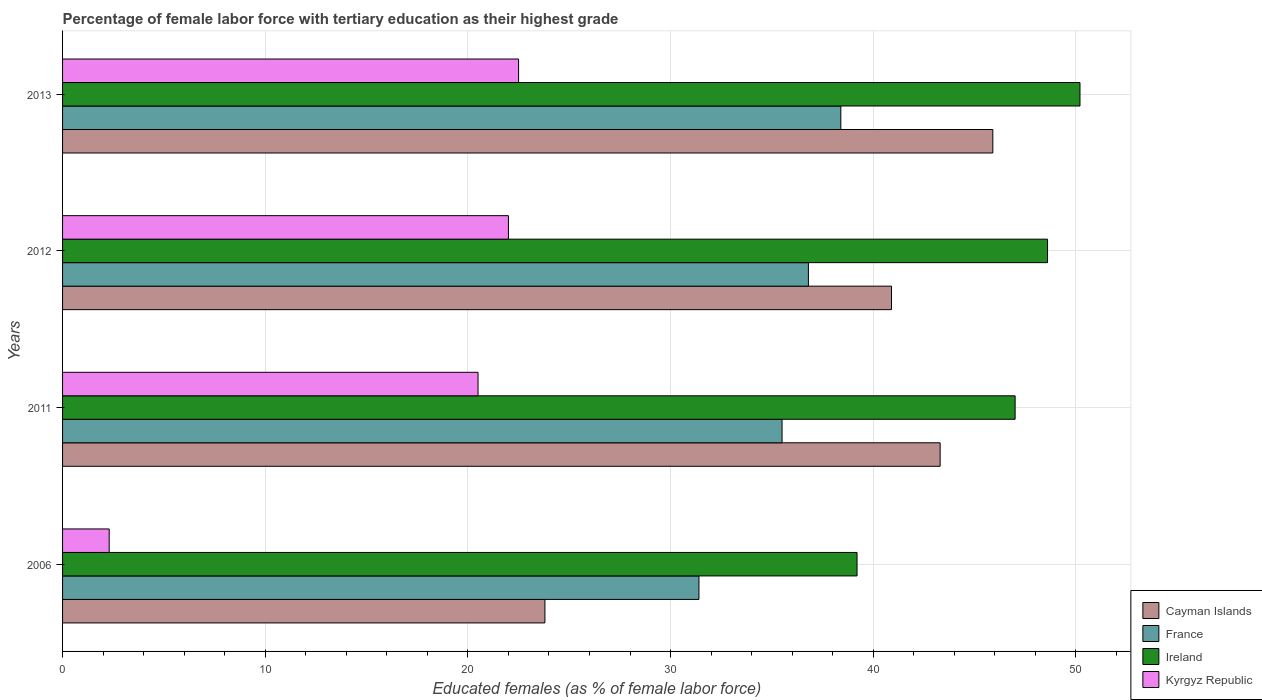Are the number of bars on each tick of the Y-axis equal?
Keep it short and to the point. Yes. How many bars are there on the 1st tick from the top?
Provide a short and direct response. 4. What is the label of the 1st group of bars from the top?
Make the answer very short. 2013. What is the percentage of female labor force with tertiary education in France in 2012?
Give a very brief answer. 36.8. Across all years, what is the maximum percentage of female labor force with tertiary education in Cayman Islands?
Your response must be concise. 45.9. Across all years, what is the minimum percentage of female labor force with tertiary education in Cayman Islands?
Offer a very short reply. 23.8. What is the total percentage of female labor force with tertiary education in Kyrgyz Republic in the graph?
Give a very brief answer. 67.3. What is the difference between the percentage of female labor force with tertiary education in Ireland in 2011 and that in 2013?
Make the answer very short. -3.2. What is the difference between the percentage of female labor force with tertiary education in Ireland in 2006 and the percentage of female labor force with tertiary education in Cayman Islands in 2012?
Provide a short and direct response. -1.7. What is the average percentage of female labor force with tertiary education in France per year?
Provide a succinct answer. 35.53. In the year 2011, what is the difference between the percentage of female labor force with tertiary education in Kyrgyz Republic and percentage of female labor force with tertiary education in Ireland?
Your answer should be compact. -26.5. In how many years, is the percentage of female labor force with tertiary education in Cayman Islands greater than 38 %?
Your answer should be compact. 3. What is the ratio of the percentage of female labor force with tertiary education in Ireland in 2006 to that in 2013?
Your answer should be compact. 0.78. Is the percentage of female labor force with tertiary education in Cayman Islands in 2011 less than that in 2012?
Make the answer very short. No. Is the difference between the percentage of female labor force with tertiary education in Kyrgyz Republic in 2006 and 2012 greater than the difference between the percentage of female labor force with tertiary education in Ireland in 2006 and 2012?
Your response must be concise. No. What is the difference between the highest and the lowest percentage of female labor force with tertiary education in Ireland?
Ensure brevity in your answer.  11. Is the sum of the percentage of female labor force with tertiary education in France in 2011 and 2012 greater than the maximum percentage of female labor force with tertiary education in Kyrgyz Republic across all years?
Your answer should be very brief. Yes. Is it the case that in every year, the sum of the percentage of female labor force with tertiary education in Cayman Islands and percentage of female labor force with tertiary education in Kyrgyz Republic is greater than the sum of percentage of female labor force with tertiary education in France and percentage of female labor force with tertiary education in Ireland?
Ensure brevity in your answer.  No. What does the 4th bar from the top in 2012 represents?
Offer a very short reply. Cayman Islands. What does the 2nd bar from the bottom in 2011 represents?
Make the answer very short. France. Is it the case that in every year, the sum of the percentage of female labor force with tertiary education in Cayman Islands and percentage of female labor force with tertiary education in France is greater than the percentage of female labor force with tertiary education in Ireland?
Offer a very short reply. Yes. How many bars are there?
Keep it short and to the point. 16. Are all the bars in the graph horizontal?
Offer a very short reply. Yes. What is the difference between two consecutive major ticks on the X-axis?
Offer a terse response. 10. Does the graph contain any zero values?
Give a very brief answer. No. Does the graph contain grids?
Make the answer very short. Yes. Where does the legend appear in the graph?
Provide a short and direct response. Bottom right. What is the title of the graph?
Ensure brevity in your answer.  Percentage of female labor force with tertiary education as their highest grade. What is the label or title of the X-axis?
Make the answer very short. Educated females (as % of female labor force). What is the Educated females (as % of female labor force) of Cayman Islands in 2006?
Provide a succinct answer. 23.8. What is the Educated females (as % of female labor force) of France in 2006?
Your answer should be very brief. 31.4. What is the Educated females (as % of female labor force) of Ireland in 2006?
Ensure brevity in your answer.  39.2. What is the Educated females (as % of female labor force) of Kyrgyz Republic in 2006?
Give a very brief answer. 2.3. What is the Educated females (as % of female labor force) of Cayman Islands in 2011?
Provide a short and direct response. 43.3. What is the Educated females (as % of female labor force) in France in 2011?
Ensure brevity in your answer.  35.5. What is the Educated females (as % of female labor force) of Ireland in 2011?
Your answer should be very brief. 47. What is the Educated females (as % of female labor force) of Cayman Islands in 2012?
Offer a terse response. 40.9. What is the Educated females (as % of female labor force) in France in 2012?
Provide a short and direct response. 36.8. What is the Educated females (as % of female labor force) in Ireland in 2012?
Ensure brevity in your answer.  48.6. What is the Educated females (as % of female labor force) in Kyrgyz Republic in 2012?
Your answer should be very brief. 22. What is the Educated females (as % of female labor force) in Cayman Islands in 2013?
Your response must be concise. 45.9. What is the Educated females (as % of female labor force) in France in 2013?
Provide a short and direct response. 38.4. What is the Educated females (as % of female labor force) of Ireland in 2013?
Provide a short and direct response. 50.2. What is the Educated females (as % of female labor force) of Kyrgyz Republic in 2013?
Give a very brief answer. 22.5. Across all years, what is the maximum Educated females (as % of female labor force) in Cayman Islands?
Your answer should be very brief. 45.9. Across all years, what is the maximum Educated females (as % of female labor force) of France?
Your response must be concise. 38.4. Across all years, what is the maximum Educated females (as % of female labor force) of Ireland?
Give a very brief answer. 50.2. Across all years, what is the minimum Educated females (as % of female labor force) in Cayman Islands?
Your answer should be very brief. 23.8. Across all years, what is the minimum Educated females (as % of female labor force) in France?
Offer a terse response. 31.4. Across all years, what is the minimum Educated females (as % of female labor force) in Ireland?
Your answer should be very brief. 39.2. Across all years, what is the minimum Educated females (as % of female labor force) in Kyrgyz Republic?
Keep it short and to the point. 2.3. What is the total Educated females (as % of female labor force) in Cayman Islands in the graph?
Offer a very short reply. 153.9. What is the total Educated females (as % of female labor force) of France in the graph?
Make the answer very short. 142.1. What is the total Educated females (as % of female labor force) in Ireland in the graph?
Your answer should be very brief. 185. What is the total Educated females (as % of female labor force) of Kyrgyz Republic in the graph?
Your answer should be very brief. 67.3. What is the difference between the Educated females (as % of female labor force) of Cayman Islands in 2006 and that in 2011?
Your answer should be very brief. -19.5. What is the difference between the Educated females (as % of female labor force) of France in 2006 and that in 2011?
Provide a succinct answer. -4.1. What is the difference between the Educated females (as % of female labor force) of Kyrgyz Republic in 2006 and that in 2011?
Your answer should be compact. -18.2. What is the difference between the Educated females (as % of female labor force) in Cayman Islands in 2006 and that in 2012?
Keep it short and to the point. -17.1. What is the difference between the Educated females (as % of female labor force) of France in 2006 and that in 2012?
Your answer should be very brief. -5.4. What is the difference between the Educated females (as % of female labor force) in Ireland in 2006 and that in 2012?
Offer a terse response. -9.4. What is the difference between the Educated females (as % of female labor force) of Kyrgyz Republic in 2006 and that in 2012?
Give a very brief answer. -19.7. What is the difference between the Educated females (as % of female labor force) of Cayman Islands in 2006 and that in 2013?
Provide a short and direct response. -22.1. What is the difference between the Educated females (as % of female labor force) of Kyrgyz Republic in 2006 and that in 2013?
Keep it short and to the point. -20.2. What is the difference between the Educated females (as % of female labor force) of France in 2011 and that in 2012?
Keep it short and to the point. -1.3. What is the difference between the Educated females (as % of female labor force) in Kyrgyz Republic in 2011 and that in 2012?
Provide a succinct answer. -1.5. What is the difference between the Educated females (as % of female labor force) of Cayman Islands in 2011 and that in 2013?
Provide a succinct answer. -2.6. What is the difference between the Educated females (as % of female labor force) of France in 2011 and that in 2013?
Keep it short and to the point. -2.9. What is the difference between the Educated females (as % of female labor force) in Ireland in 2011 and that in 2013?
Make the answer very short. -3.2. What is the difference between the Educated females (as % of female labor force) in Kyrgyz Republic in 2011 and that in 2013?
Make the answer very short. -2. What is the difference between the Educated females (as % of female labor force) in Cayman Islands in 2012 and that in 2013?
Provide a short and direct response. -5. What is the difference between the Educated females (as % of female labor force) in France in 2012 and that in 2013?
Your response must be concise. -1.6. What is the difference between the Educated females (as % of female labor force) in Ireland in 2012 and that in 2013?
Keep it short and to the point. -1.6. What is the difference between the Educated females (as % of female labor force) in Kyrgyz Republic in 2012 and that in 2013?
Offer a very short reply. -0.5. What is the difference between the Educated females (as % of female labor force) in Cayman Islands in 2006 and the Educated females (as % of female labor force) in France in 2011?
Make the answer very short. -11.7. What is the difference between the Educated females (as % of female labor force) of Cayman Islands in 2006 and the Educated females (as % of female labor force) of Ireland in 2011?
Provide a short and direct response. -23.2. What is the difference between the Educated females (as % of female labor force) in Cayman Islands in 2006 and the Educated females (as % of female labor force) in Kyrgyz Republic in 2011?
Your response must be concise. 3.3. What is the difference between the Educated females (as % of female labor force) in France in 2006 and the Educated females (as % of female labor force) in Ireland in 2011?
Ensure brevity in your answer.  -15.6. What is the difference between the Educated females (as % of female labor force) of France in 2006 and the Educated females (as % of female labor force) of Kyrgyz Republic in 2011?
Give a very brief answer. 10.9. What is the difference between the Educated females (as % of female labor force) in Cayman Islands in 2006 and the Educated females (as % of female labor force) in France in 2012?
Keep it short and to the point. -13. What is the difference between the Educated females (as % of female labor force) of Cayman Islands in 2006 and the Educated females (as % of female labor force) of Ireland in 2012?
Make the answer very short. -24.8. What is the difference between the Educated females (as % of female labor force) of Cayman Islands in 2006 and the Educated females (as % of female labor force) of Kyrgyz Republic in 2012?
Your answer should be very brief. 1.8. What is the difference between the Educated females (as % of female labor force) of France in 2006 and the Educated females (as % of female labor force) of Ireland in 2012?
Provide a succinct answer. -17.2. What is the difference between the Educated females (as % of female labor force) in France in 2006 and the Educated females (as % of female labor force) in Kyrgyz Republic in 2012?
Make the answer very short. 9.4. What is the difference between the Educated females (as % of female labor force) of Ireland in 2006 and the Educated females (as % of female labor force) of Kyrgyz Republic in 2012?
Offer a very short reply. 17.2. What is the difference between the Educated females (as % of female labor force) in Cayman Islands in 2006 and the Educated females (as % of female labor force) in France in 2013?
Ensure brevity in your answer.  -14.6. What is the difference between the Educated females (as % of female labor force) in Cayman Islands in 2006 and the Educated females (as % of female labor force) in Ireland in 2013?
Provide a succinct answer. -26.4. What is the difference between the Educated females (as % of female labor force) of Cayman Islands in 2006 and the Educated females (as % of female labor force) of Kyrgyz Republic in 2013?
Your answer should be very brief. 1.3. What is the difference between the Educated females (as % of female labor force) of France in 2006 and the Educated females (as % of female labor force) of Ireland in 2013?
Make the answer very short. -18.8. What is the difference between the Educated females (as % of female labor force) in Cayman Islands in 2011 and the Educated females (as % of female labor force) in France in 2012?
Keep it short and to the point. 6.5. What is the difference between the Educated females (as % of female labor force) in Cayman Islands in 2011 and the Educated females (as % of female labor force) in Kyrgyz Republic in 2012?
Your answer should be very brief. 21.3. What is the difference between the Educated females (as % of female labor force) of France in 2011 and the Educated females (as % of female labor force) of Kyrgyz Republic in 2012?
Offer a terse response. 13.5. What is the difference between the Educated females (as % of female labor force) in Ireland in 2011 and the Educated females (as % of female labor force) in Kyrgyz Republic in 2012?
Make the answer very short. 25. What is the difference between the Educated females (as % of female labor force) of Cayman Islands in 2011 and the Educated females (as % of female labor force) of Kyrgyz Republic in 2013?
Your answer should be compact. 20.8. What is the difference between the Educated females (as % of female labor force) of France in 2011 and the Educated females (as % of female labor force) of Ireland in 2013?
Provide a short and direct response. -14.7. What is the difference between the Educated females (as % of female labor force) in France in 2011 and the Educated females (as % of female labor force) in Kyrgyz Republic in 2013?
Your response must be concise. 13. What is the difference between the Educated females (as % of female labor force) in Ireland in 2011 and the Educated females (as % of female labor force) in Kyrgyz Republic in 2013?
Your response must be concise. 24.5. What is the difference between the Educated females (as % of female labor force) in Cayman Islands in 2012 and the Educated females (as % of female labor force) in Ireland in 2013?
Provide a succinct answer. -9.3. What is the difference between the Educated females (as % of female labor force) of Cayman Islands in 2012 and the Educated females (as % of female labor force) of Kyrgyz Republic in 2013?
Make the answer very short. 18.4. What is the difference between the Educated females (as % of female labor force) of France in 2012 and the Educated females (as % of female labor force) of Ireland in 2013?
Offer a terse response. -13.4. What is the difference between the Educated females (as % of female labor force) in Ireland in 2012 and the Educated females (as % of female labor force) in Kyrgyz Republic in 2013?
Your answer should be very brief. 26.1. What is the average Educated females (as % of female labor force) of Cayman Islands per year?
Your response must be concise. 38.48. What is the average Educated females (as % of female labor force) of France per year?
Keep it short and to the point. 35.52. What is the average Educated females (as % of female labor force) of Ireland per year?
Ensure brevity in your answer.  46.25. What is the average Educated females (as % of female labor force) of Kyrgyz Republic per year?
Ensure brevity in your answer.  16.82. In the year 2006, what is the difference between the Educated females (as % of female labor force) of Cayman Islands and Educated females (as % of female labor force) of Ireland?
Keep it short and to the point. -15.4. In the year 2006, what is the difference between the Educated females (as % of female labor force) in Cayman Islands and Educated females (as % of female labor force) in Kyrgyz Republic?
Your answer should be very brief. 21.5. In the year 2006, what is the difference between the Educated females (as % of female labor force) of France and Educated females (as % of female labor force) of Kyrgyz Republic?
Ensure brevity in your answer.  29.1. In the year 2006, what is the difference between the Educated females (as % of female labor force) in Ireland and Educated females (as % of female labor force) in Kyrgyz Republic?
Offer a very short reply. 36.9. In the year 2011, what is the difference between the Educated females (as % of female labor force) in Cayman Islands and Educated females (as % of female labor force) in France?
Provide a succinct answer. 7.8. In the year 2011, what is the difference between the Educated females (as % of female labor force) of Cayman Islands and Educated females (as % of female labor force) of Ireland?
Offer a very short reply. -3.7. In the year 2011, what is the difference between the Educated females (as % of female labor force) of Cayman Islands and Educated females (as % of female labor force) of Kyrgyz Republic?
Your answer should be very brief. 22.8. In the year 2011, what is the difference between the Educated females (as % of female labor force) in France and Educated females (as % of female labor force) in Ireland?
Make the answer very short. -11.5. In the year 2011, what is the difference between the Educated females (as % of female labor force) of Ireland and Educated females (as % of female labor force) of Kyrgyz Republic?
Keep it short and to the point. 26.5. In the year 2012, what is the difference between the Educated females (as % of female labor force) of Cayman Islands and Educated females (as % of female labor force) of France?
Offer a terse response. 4.1. In the year 2012, what is the difference between the Educated females (as % of female labor force) of France and Educated females (as % of female labor force) of Ireland?
Offer a terse response. -11.8. In the year 2012, what is the difference between the Educated females (as % of female labor force) of France and Educated females (as % of female labor force) of Kyrgyz Republic?
Offer a very short reply. 14.8. In the year 2012, what is the difference between the Educated females (as % of female labor force) in Ireland and Educated females (as % of female labor force) in Kyrgyz Republic?
Your answer should be very brief. 26.6. In the year 2013, what is the difference between the Educated females (as % of female labor force) in Cayman Islands and Educated females (as % of female labor force) in France?
Make the answer very short. 7.5. In the year 2013, what is the difference between the Educated females (as % of female labor force) in Cayman Islands and Educated females (as % of female labor force) in Kyrgyz Republic?
Ensure brevity in your answer.  23.4. In the year 2013, what is the difference between the Educated females (as % of female labor force) in France and Educated females (as % of female labor force) in Ireland?
Ensure brevity in your answer.  -11.8. In the year 2013, what is the difference between the Educated females (as % of female labor force) in Ireland and Educated females (as % of female labor force) in Kyrgyz Republic?
Keep it short and to the point. 27.7. What is the ratio of the Educated females (as % of female labor force) of Cayman Islands in 2006 to that in 2011?
Your answer should be compact. 0.55. What is the ratio of the Educated females (as % of female labor force) in France in 2006 to that in 2011?
Offer a very short reply. 0.88. What is the ratio of the Educated females (as % of female labor force) of Ireland in 2006 to that in 2011?
Keep it short and to the point. 0.83. What is the ratio of the Educated females (as % of female labor force) of Kyrgyz Republic in 2006 to that in 2011?
Provide a succinct answer. 0.11. What is the ratio of the Educated females (as % of female labor force) in Cayman Islands in 2006 to that in 2012?
Provide a short and direct response. 0.58. What is the ratio of the Educated females (as % of female labor force) of France in 2006 to that in 2012?
Your answer should be compact. 0.85. What is the ratio of the Educated females (as % of female labor force) of Ireland in 2006 to that in 2012?
Provide a succinct answer. 0.81. What is the ratio of the Educated females (as % of female labor force) in Kyrgyz Republic in 2006 to that in 2012?
Make the answer very short. 0.1. What is the ratio of the Educated females (as % of female labor force) in Cayman Islands in 2006 to that in 2013?
Make the answer very short. 0.52. What is the ratio of the Educated females (as % of female labor force) of France in 2006 to that in 2013?
Offer a very short reply. 0.82. What is the ratio of the Educated females (as % of female labor force) in Ireland in 2006 to that in 2013?
Ensure brevity in your answer.  0.78. What is the ratio of the Educated females (as % of female labor force) in Kyrgyz Republic in 2006 to that in 2013?
Give a very brief answer. 0.1. What is the ratio of the Educated females (as % of female labor force) in Cayman Islands in 2011 to that in 2012?
Offer a very short reply. 1.06. What is the ratio of the Educated females (as % of female labor force) in France in 2011 to that in 2012?
Your response must be concise. 0.96. What is the ratio of the Educated females (as % of female labor force) in Ireland in 2011 to that in 2012?
Offer a terse response. 0.97. What is the ratio of the Educated females (as % of female labor force) of Kyrgyz Republic in 2011 to that in 2012?
Provide a short and direct response. 0.93. What is the ratio of the Educated females (as % of female labor force) in Cayman Islands in 2011 to that in 2013?
Your answer should be very brief. 0.94. What is the ratio of the Educated females (as % of female labor force) in France in 2011 to that in 2013?
Offer a very short reply. 0.92. What is the ratio of the Educated females (as % of female labor force) in Ireland in 2011 to that in 2013?
Your response must be concise. 0.94. What is the ratio of the Educated females (as % of female labor force) in Kyrgyz Republic in 2011 to that in 2013?
Your answer should be compact. 0.91. What is the ratio of the Educated females (as % of female labor force) in Cayman Islands in 2012 to that in 2013?
Give a very brief answer. 0.89. What is the ratio of the Educated females (as % of female labor force) in France in 2012 to that in 2013?
Your answer should be compact. 0.96. What is the ratio of the Educated females (as % of female labor force) in Ireland in 2012 to that in 2013?
Keep it short and to the point. 0.97. What is the ratio of the Educated females (as % of female labor force) in Kyrgyz Republic in 2012 to that in 2013?
Offer a terse response. 0.98. What is the difference between the highest and the second highest Educated females (as % of female labor force) in Cayman Islands?
Your response must be concise. 2.6. What is the difference between the highest and the second highest Educated females (as % of female labor force) of Kyrgyz Republic?
Give a very brief answer. 0.5. What is the difference between the highest and the lowest Educated females (as % of female labor force) of Cayman Islands?
Keep it short and to the point. 22.1. What is the difference between the highest and the lowest Educated females (as % of female labor force) in Kyrgyz Republic?
Keep it short and to the point. 20.2. 